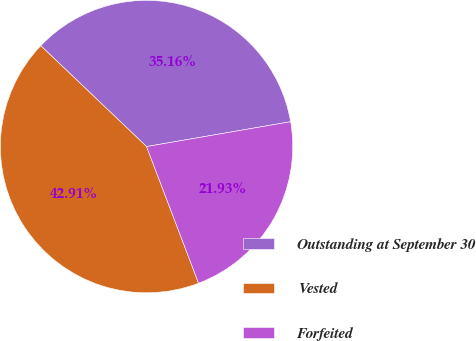<chart> <loc_0><loc_0><loc_500><loc_500><pie_chart><fcel>Outstanding at September 30<fcel>Vested<fcel>Forfeited<nl><fcel>35.16%<fcel>42.91%<fcel>21.93%<nl></chart> 